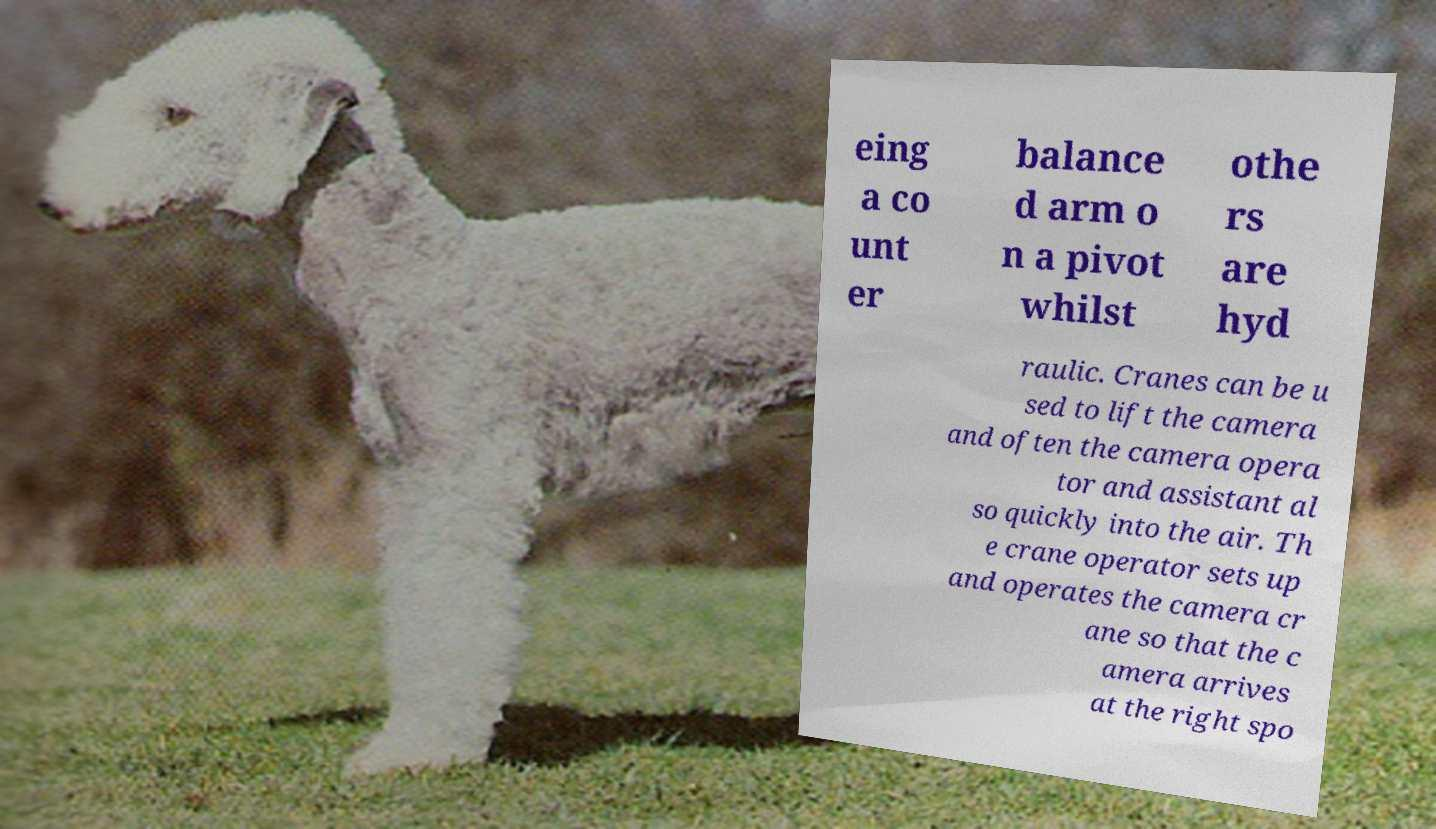I need the written content from this picture converted into text. Can you do that? eing a co unt er balance d arm o n a pivot whilst othe rs are hyd raulic. Cranes can be u sed to lift the camera and often the camera opera tor and assistant al so quickly into the air. Th e crane operator sets up and operates the camera cr ane so that the c amera arrives at the right spo 